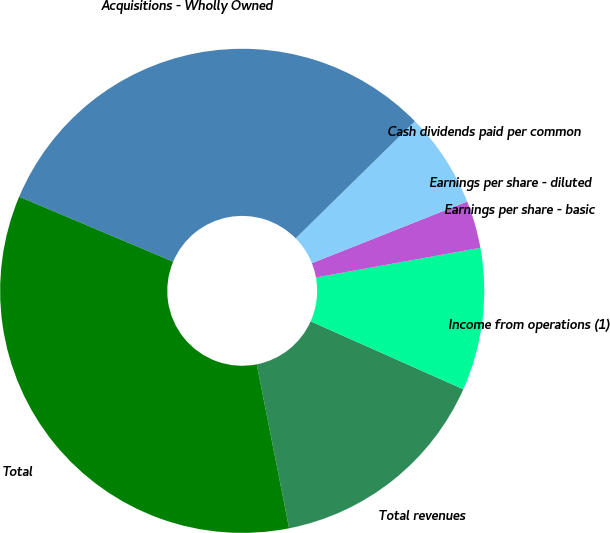Convert chart. <chart><loc_0><loc_0><loc_500><loc_500><pie_chart><fcel>Total revenues<fcel>Income from operations (1)<fcel>Earnings per share - basic<fcel>Earnings per share - diluted<fcel>Cash dividends paid per common<fcel>Acquisitions - Wholly Owned<fcel>Total<nl><fcel>15.23%<fcel>9.51%<fcel>3.17%<fcel>0.0%<fcel>6.34%<fcel>31.29%<fcel>34.46%<nl></chart> 